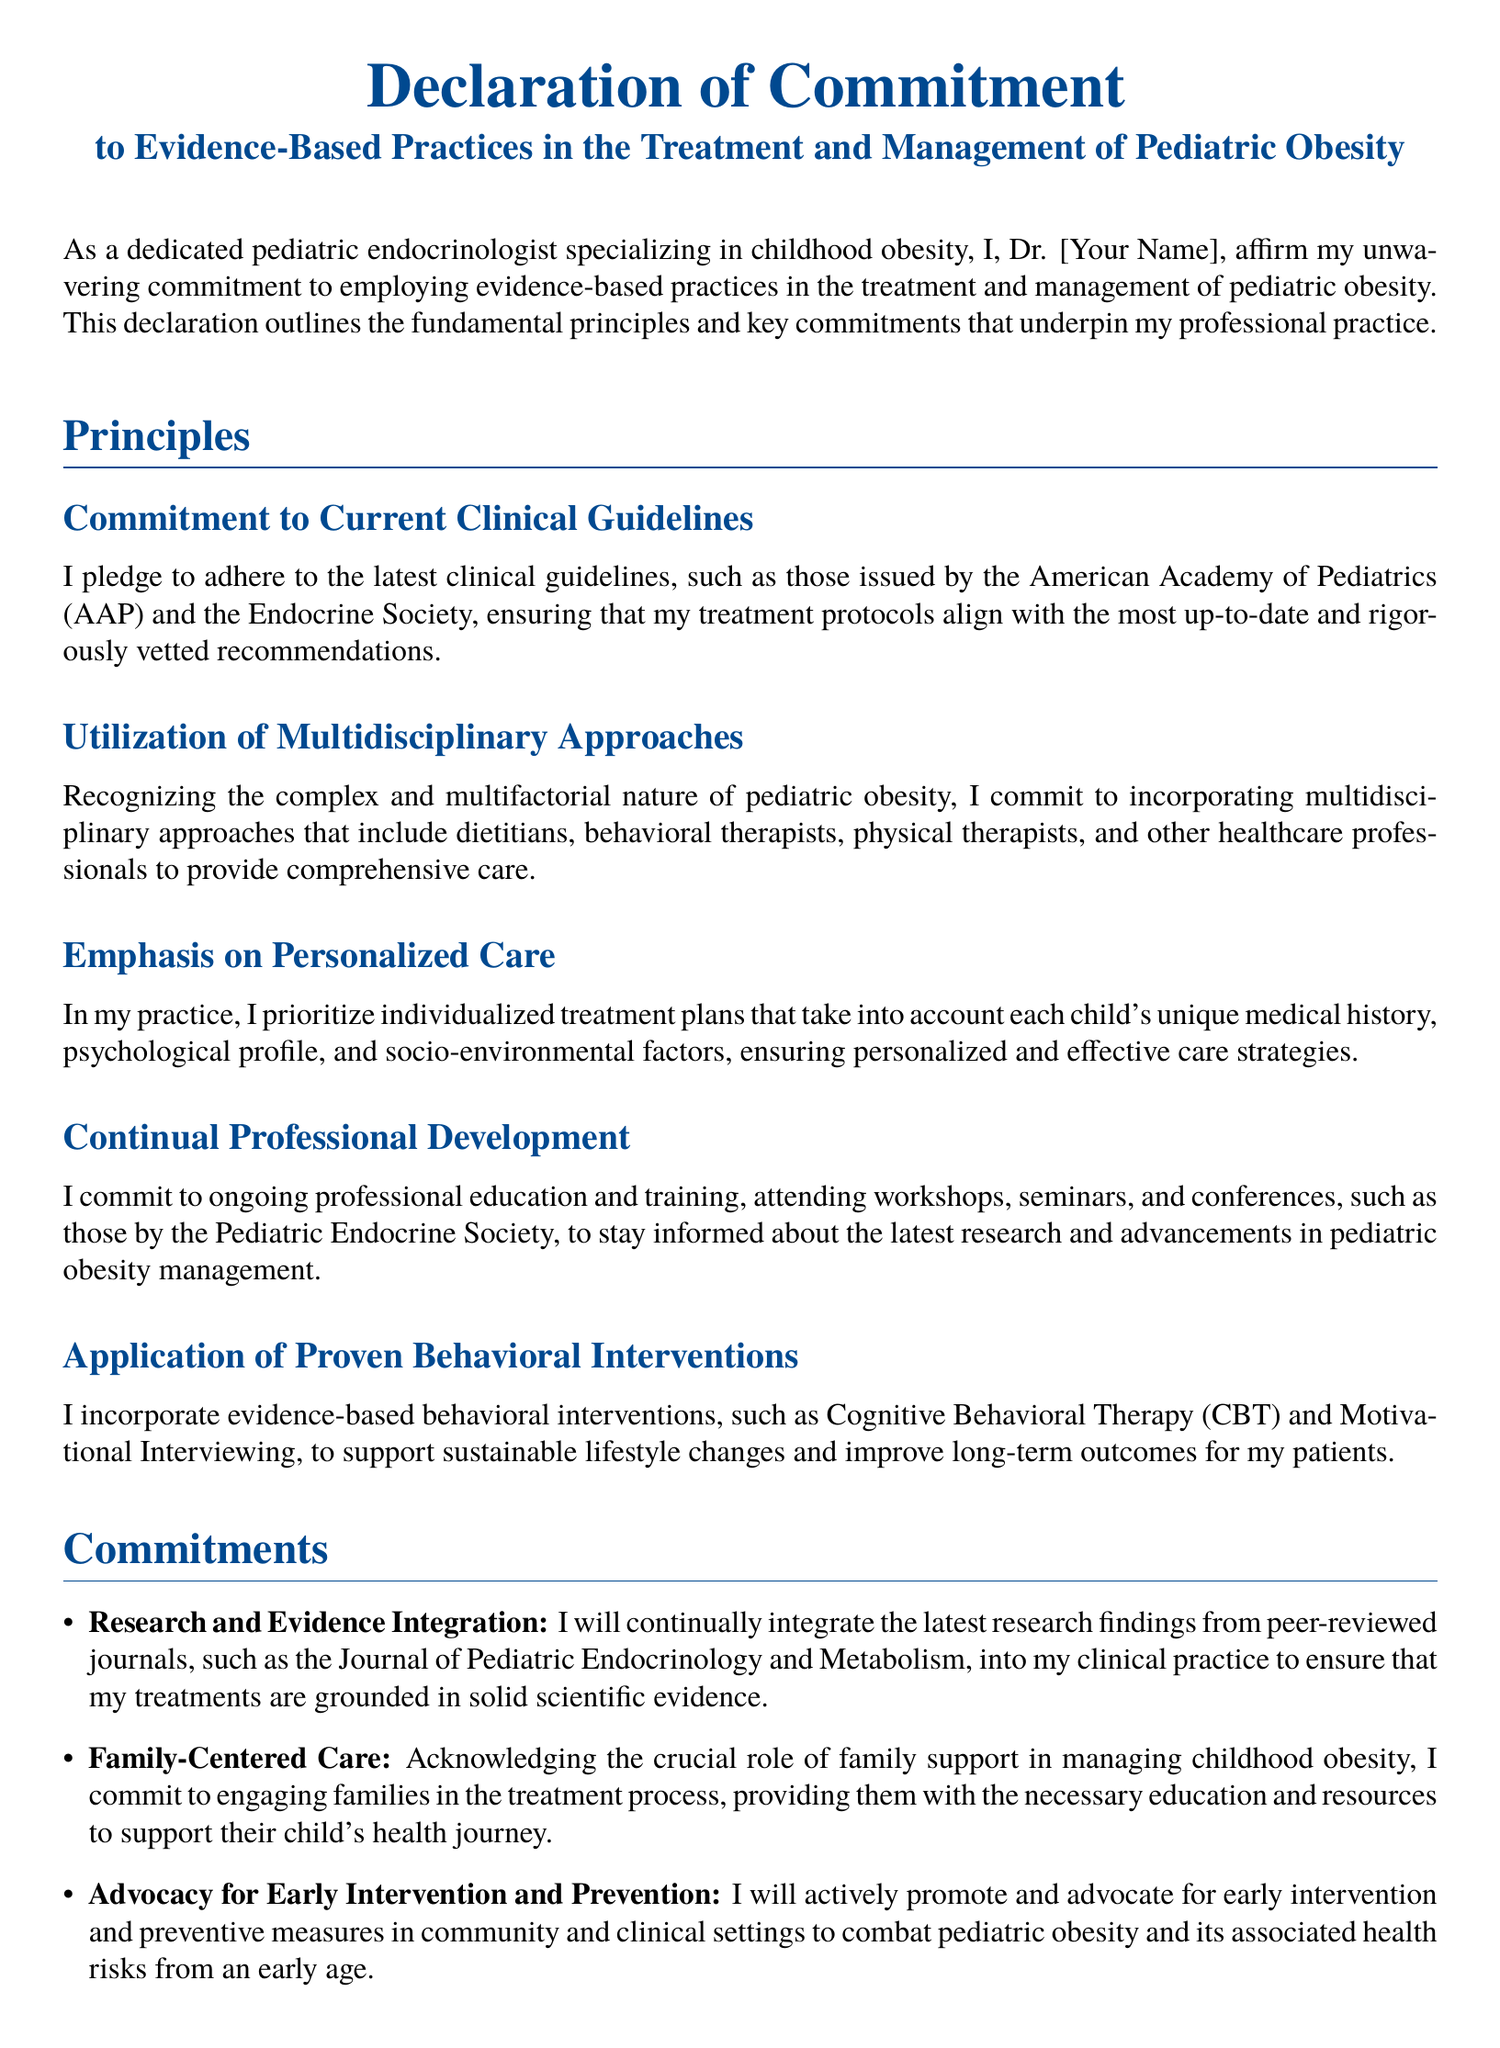What is the title of the document? The title of the document is stated clearly at the top and indicates its purpose and focus.
Answer: Declaration of Commitment to Evidence-Based Practices in the Treatment and Management of Pediatric Obesity Who is the author of the declaration? The author is indicated in the declaration as the signatory affirming the commitments outlined.
Answer: Dr. [Your Name] What principle emphasizes the importance of families in treatment? The document specifically outlines commitments that involve family engagement in the patient care approach.
Answer: Family-Centered Care Which organization’s guidelines is the commitment aligned with? The commitment to clinical guidelines refers specifically to established professional organizations in the field of pediatrics.
Answer: American Academy of Pediatrics What intervention methods are mentioned for supporting lifestyle changes? The document highlights specific behavioral approaches utilized in treating childhood obesity.
Answer: Cognitive Behavioral Therapy and Motivational Interviewing How often does the author commit to professional development? The commitment to professional growth suggests a continual effort in learning and improvement according to current standards.
Answer: Ongoing What is the author's stance on ethical principles? The author asserts a clear commitment to ethical practices within the scope of their treatment strategies.
Answer: Ethical and Compassionate Care What type of care does the author prioritize? The commitment to personalized treatment approaches is emphasized for effective management of pediatric obesity.
Answer: Personalized Care 